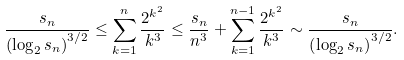Convert formula to latex. <formula><loc_0><loc_0><loc_500><loc_500>\frac { s _ { n } } { \left ( { \log _ { 2 } s _ { n } } \right ) ^ { 3 / 2 } } & \leq \sum _ { k = 1 } ^ { n } \frac { 2 ^ { k ^ { 2 } } } { k ^ { 3 } } \leq \frac { s _ { n } } { n ^ { 3 } } + \sum _ { k = 1 } ^ { n - 1 } \frac { 2 ^ { k ^ { 2 } } } { k ^ { 3 } } \sim \frac { s _ { n } } { \left ( { \log _ { 2 } s _ { n } } \right ) ^ { 3 / 2 } } .</formula> 